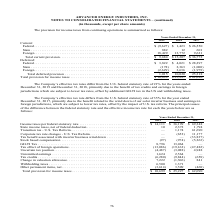According to Advanced Energy's financial document, Why did the company's effective tax rate differ from the U.S. federal statutory rate? due to the benefit related to the wind down of our solar inverter business and earnings in foreign jurisdictions, which are subject to lower tax rates, offset by the impact of U.S. tax reform.. The document states: "5% for the year ended December 31, 2017, primarily due to the benefit related to the wind down of our solar inverter business and earnings in foreign ..." Also, What was the Income taxes per federal statutory rate in 2018? According to the financial document, $36,199 (in thousands). The relevant text states: "ome taxes per federal statutory rate . $ 14,111 $ 36,199 $ 69,348 State income taxes, net of federal deduction . 10 2,372 1,794 Transition tax - U.S. Tax Re..." Also, What was the State income taxes, net of federal deduction in 2017? According to the financial document, 1,794 (in thousands). The relevant text states: "income taxes, net of federal deduction . 10 2,372 1,794 Transition tax - U.S. Tax Reform . — 1,174 61,690 Corporate tax rate changes - U.S. Tax Reform . —..." Also, can you calculate: What was the change in GILTI Tax between 2018 and 2019? Based on the calculation: 8,796-13,064, the result is -4268 (in thousands). This is based on the information: "sed compensation . (97) (974) (5,263) GILTI Tax . 8,796 13,064 — Tax effect of foreign operations . (13,086) (19,162) (47,482) Uncertain tax position . (4, mpensation . (97) (974) (5,263) GILTI Tax . ..." The key data points involved are: 13,064, 8,796. Also, can you calculate: What was the change in Unremitted earnings between 2018 and 2019? Based on the calculation: 1,624-2,564, the result is -940 (in thousands). This is based on the information: "(4,487) (3,088) 4,948 Unremitted earnings . 1,624 2,564 — Tax credits . (6,280) (9,844) (658) Change in valuation allowance . 7,222 (1,306) 841 Withholding ion . (4,487) (3,088) 4,948 Unremitted earni..." The key data points involved are: 1,624, 2,564. Also, can you calculate: What was the percentage change in Withholding taxes between 2018 and 2019? To answer this question, I need to perform calculations using the financial data. The calculation is: (6,500-1,371)/1,371, which equals 374.11 (percentage). This is based on the information: "nce . 7,222 (1,306) 841 Withholding taxes . 6,500 1,371 — Other permanent items, net . (3,614) 3,509 (468) Total provision for income taxes . $ 10,699 $ 25 allowance . 7,222 (1,306) 841 Withholding ta..." The key data points involved are: 1,371, 6,500. 